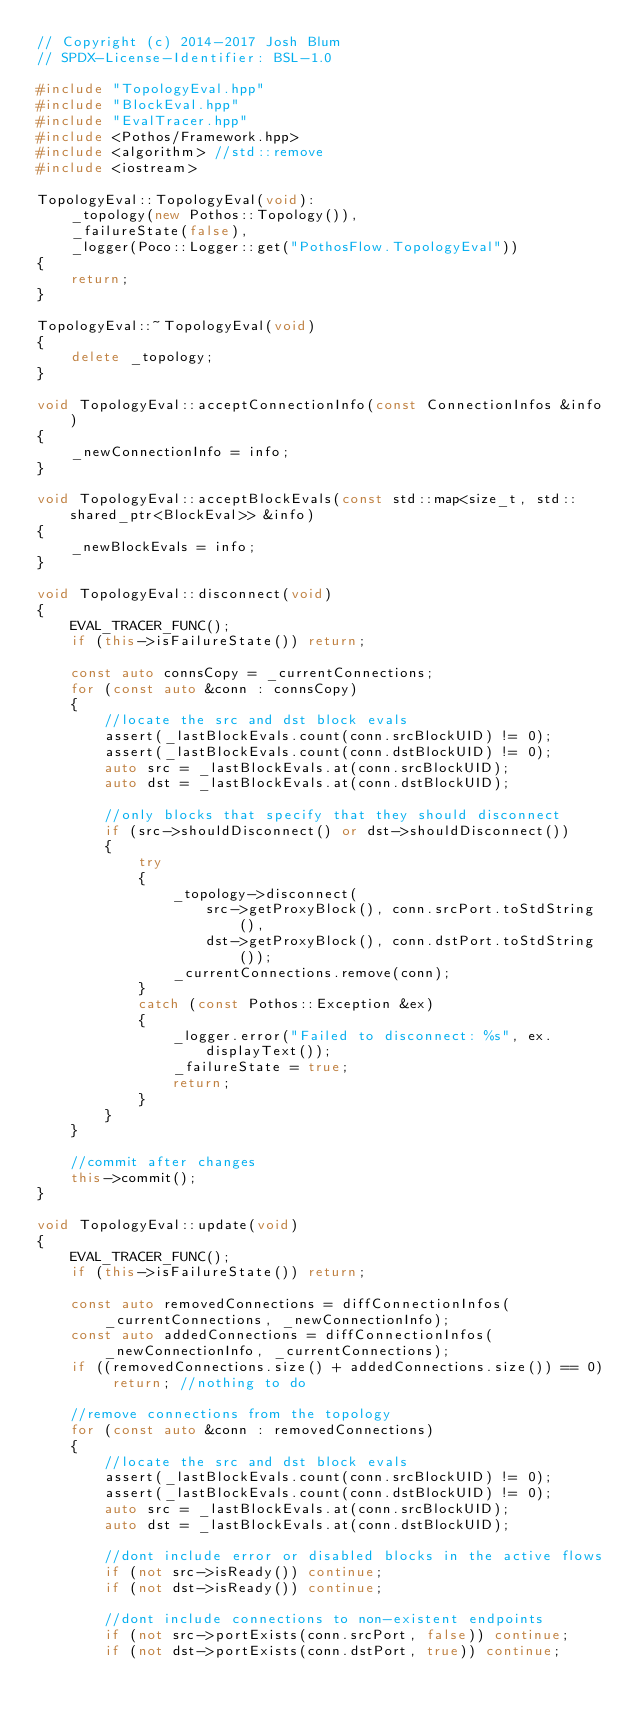<code> <loc_0><loc_0><loc_500><loc_500><_C++_>// Copyright (c) 2014-2017 Josh Blum
// SPDX-License-Identifier: BSL-1.0

#include "TopologyEval.hpp"
#include "BlockEval.hpp"
#include "EvalTracer.hpp"
#include <Pothos/Framework.hpp>
#include <algorithm> //std::remove
#include <iostream>

TopologyEval::TopologyEval(void):
    _topology(new Pothos::Topology()),
    _failureState(false),
    _logger(Poco::Logger::get("PothosFlow.TopologyEval"))
{
    return;
}

TopologyEval::~TopologyEval(void)
{
    delete _topology;
}

void TopologyEval::acceptConnectionInfo(const ConnectionInfos &info)
{
    _newConnectionInfo = info;
}

void TopologyEval::acceptBlockEvals(const std::map<size_t, std::shared_ptr<BlockEval>> &info)
{
    _newBlockEvals = info;
}

void TopologyEval::disconnect(void)
{
    EVAL_TRACER_FUNC();
    if (this->isFailureState()) return;

    const auto connsCopy = _currentConnections;
    for (const auto &conn : connsCopy)
    {
        //locate the src and dst block evals
        assert(_lastBlockEvals.count(conn.srcBlockUID) != 0);
        assert(_lastBlockEvals.count(conn.dstBlockUID) != 0);
        auto src = _lastBlockEvals.at(conn.srcBlockUID);
        auto dst = _lastBlockEvals.at(conn.dstBlockUID);

        //only blocks that specify that they should disconnect
        if (src->shouldDisconnect() or dst->shouldDisconnect())
        {
            try
            {
                _topology->disconnect(
                    src->getProxyBlock(), conn.srcPort.toStdString(),
                    dst->getProxyBlock(), conn.dstPort.toStdString());
                _currentConnections.remove(conn);
            }
            catch (const Pothos::Exception &ex)
            {
                _logger.error("Failed to disconnect: %s", ex.displayText());
                _failureState = true;
                return;
            }
        }
    }

    //commit after changes
    this->commit();
}

void TopologyEval::update(void)
{
    EVAL_TRACER_FUNC();
    if (this->isFailureState()) return;

    const auto removedConnections = diffConnectionInfos(_currentConnections, _newConnectionInfo);
    const auto addedConnections = diffConnectionInfos(_newConnectionInfo, _currentConnections);
    if ((removedConnections.size() + addedConnections.size()) == 0) return; //nothing to do

    //remove connections from the topology
    for (const auto &conn : removedConnections)
    {
        //locate the src and dst block evals
        assert(_lastBlockEvals.count(conn.srcBlockUID) != 0);
        assert(_lastBlockEvals.count(conn.dstBlockUID) != 0);
        auto src = _lastBlockEvals.at(conn.srcBlockUID);
        auto dst = _lastBlockEvals.at(conn.dstBlockUID);

        //dont include error or disabled blocks in the active flows
        if (not src->isReady()) continue;
        if (not dst->isReady()) continue;

        //dont include connections to non-existent endpoints
        if (not src->portExists(conn.srcPort, false)) continue;
        if (not dst->portExists(conn.dstPort, true)) continue;
</code> 